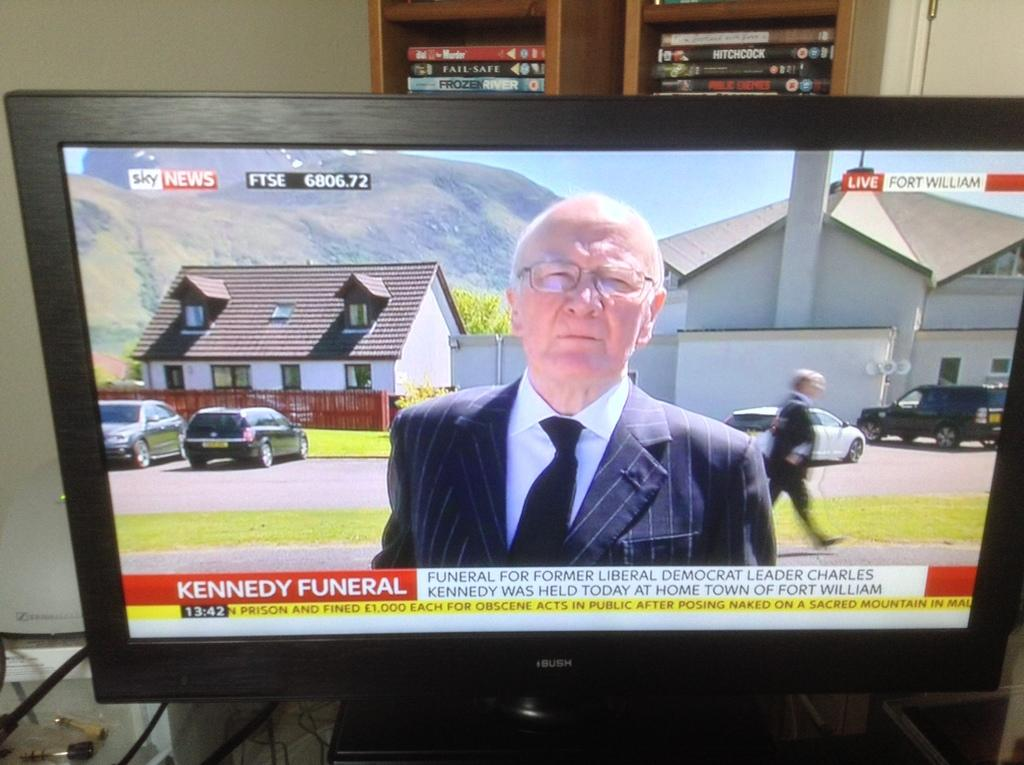<image>
Present a compact description of the photo's key features. News report on the television of Kennedy funeral. 